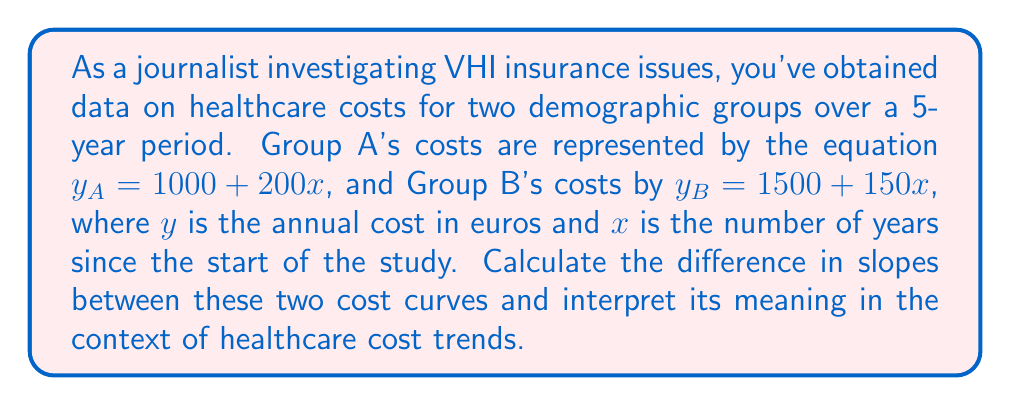Teach me how to tackle this problem. 1) First, let's identify the slope of each line from the given equations:

   For Group A: $y_A = 1000 + 200x$
   The slope is the coefficient of $x$, which is 200.

   For Group B: $y_B = 1500 + 150x$
   The slope is the coefficient of $x$, which is 150.

2) To find the difference in slopes, we subtract:
   
   Difference = Slope of Group A - Slope of Group B
               = 200 - 150 = 50

3) Interpretation:
   The slope represents the rate of change in healthcare costs per year.
   The positive difference of 50 €/year indicates that Group A's healthcare costs are increasing at a faster rate than Group B's.

4) In the context of healthcare cost trends:
   Group A's costs are rising by 200 € per year, while Group B's costs are rising by 150 € per year. The 50 € difference means that the gap in healthcare costs between these two groups is widening by 50 € each year, with Group A experiencing a more rapid increase in costs.
Answer: 50 €/year, with Group A's costs rising faster 